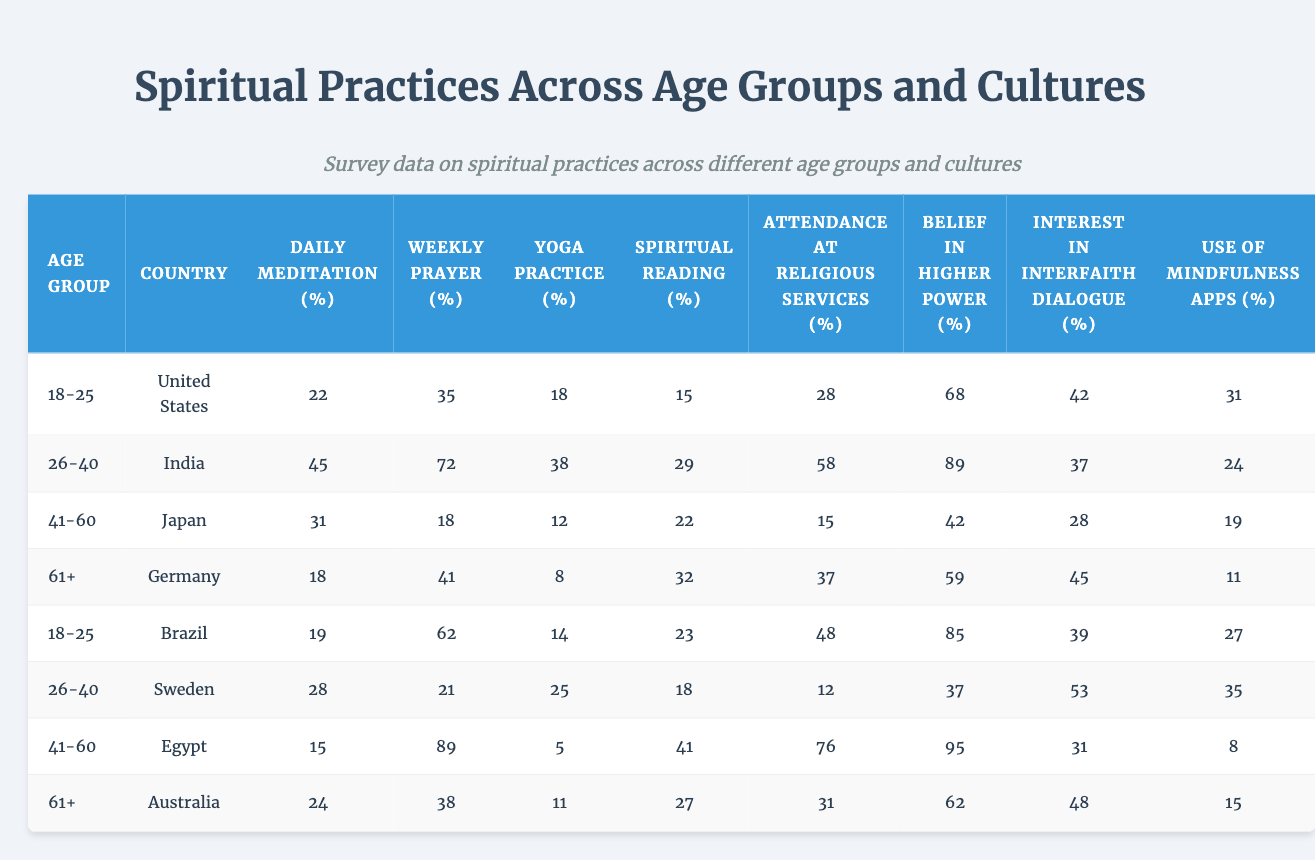What percentage of people aged 18-25 in the United States engage in daily meditation? The table shows that 22% of individuals aged 18-25 in the United States practice daily meditation.
Answer: 22% Which country has the highest percentage of individuals aged 41-60 who attend religious services? Referring to the table, Egypt has the highest percentage (76%) of individuals aged 41-60 who attend religious services.
Answer: Egypt What is the difference in percentage between weekly prayer among individuals aged 26-40 in India and Sweden? For India, the percentage is 72% and for Sweden, it is 21%. The difference is 72% - 21% = 51%.
Answer: 51% Is the belief in a higher power higher among younger people in Brazil compared to older people in Germany? In Brazil, 85% of the 18-25 age group believe in a higher power, while in Germany, 59% of the 61+ age group believe in a higher power. Since 85% is higher than 59%, the statement is true.
Answer: Yes What is the average percentage of daily meditation across all age groups in Australia? In Australia, the percentage of daily meditation only pertains to the age group 61+, which is 24%. Thus, there is only one value, so the average is also 24%.
Answer: 24% Which age group in India practices yoga the most? In India, the highest percentage of yoga practice is found in the 26-40 age group, where 38% engage in yoga.
Answer: 26-40 age group What is the combined percentage of people aged 61+ from Germany and Australia who use mindfulness apps? The table shows 11% of individuals aged 61+ in Australia and 19% in Germany. Adding these together gives 11% + 19% = 30%.
Answer: 30% How many more individuals aged 41-60 in Japan engage in spiritual reading compared to those in Egypt? In Japan, 22% engage in spiritual reading, while in Egypt, it is 41%. The difference is 41% - 22% = 19%.
Answer: 19% What percentage of people aged 18-25 in Brazil express an interest in interfaith dialogue? The table indicates that 39% of individuals aged 18-25 in Brazil have an interest in interfaith dialogue.
Answer: 39% Which country shows the lowest percentage of daily meditation for the age group 61+? According to the table, Germany has the lowest percentage of daily meditation (18%) for the age group 61+.
Answer: Germany 